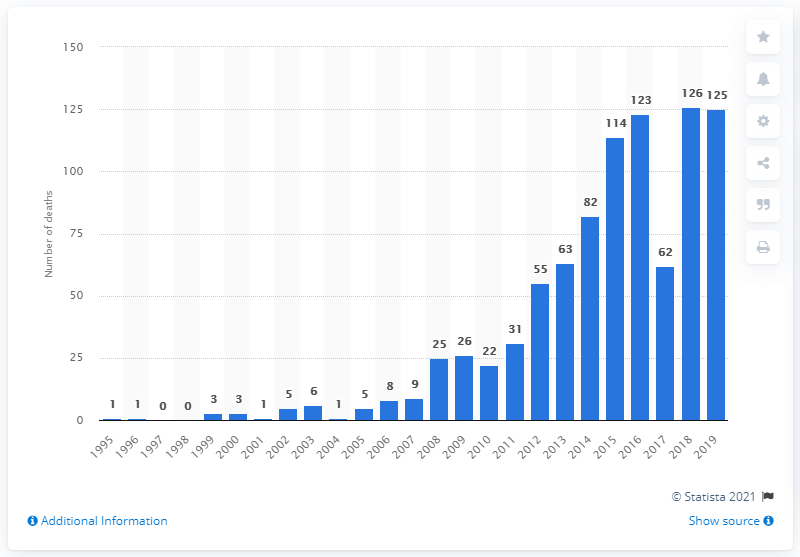Mention a couple of crucial points in this snapshot. In 2019, there were 125 deaths caused by psychoactive substances in England and Wales. The number of drug-related deaths due to the use of new psychoactive substances in England and Wales peaked in 1995. 